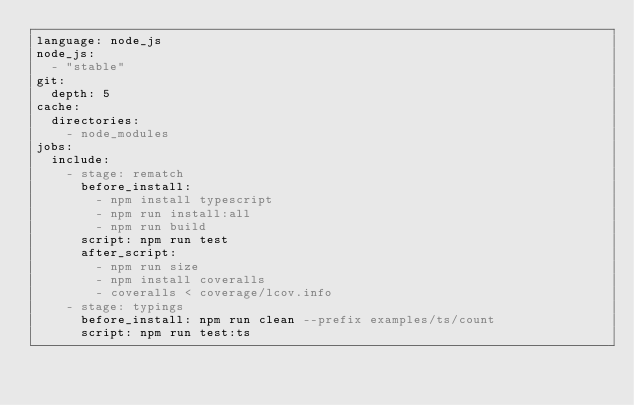Convert code to text. <code><loc_0><loc_0><loc_500><loc_500><_YAML_>language: node_js
node_js:
  - "stable"
git:
  depth: 5
cache:
  directories:
    - node_modules
jobs:
  include:
    - stage: rematch
      before_install:
        - npm install typescript
        - npm run install:all
        - npm run build
      script: npm run test
      after_script:
        - npm run size
        - npm install coveralls
        - coveralls < coverage/lcov.info          
    - stage: typings
      before_install: npm run clean --prefix examples/ts/count
      script: npm run test:ts
</code> 